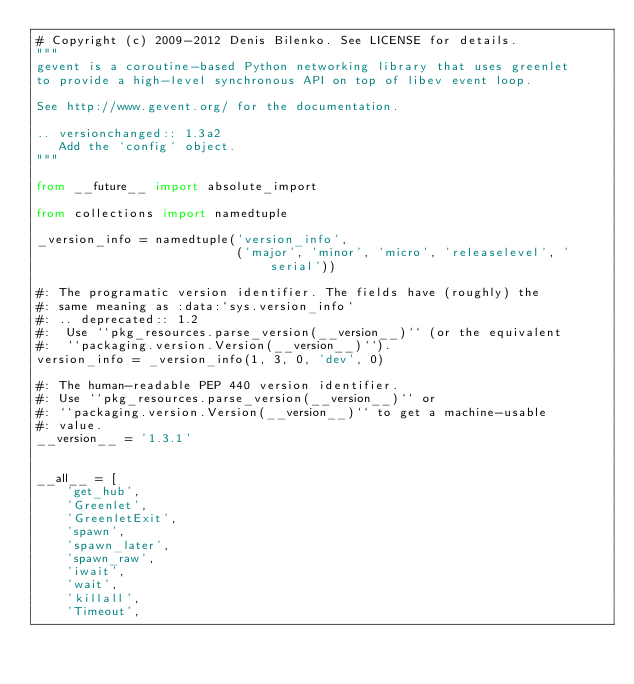<code> <loc_0><loc_0><loc_500><loc_500><_Python_># Copyright (c) 2009-2012 Denis Bilenko. See LICENSE for details.
"""
gevent is a coroutine-based Python networking library that uses greenlet
to provide a high-level synchronous API on top of libev event loop.

See http://www.gevent.org/ for the documentation.

.. versionchanged:: 1.3a2
   Add the `config` object.
"""

from __future__ import absolute_import

from collections import namedtuple

_version_info = namedtuple('version_info',
                           ('major', 'minor', 'micro', 'releaselevel', 'serial'))

#: The programatic version identifier. The fields have (roughly) the
#: same meaning as :data:`sys.version_info`
#: .. deprecated:: 1.2
#:  Use ``pkg_resources.parse_version(__version__)`` (or the equivalent
#:  ``packaging.version.Version(__version__)``).
version_info = _version_info(1, 3, 0, 'dev', 0)

#: The human-readable PEP 440 version identifier.
#: Use ``pkg_resources.parse_version(__version__)`` or
#: ``packaging.version.Version(__version__)`` to get a machine-usable
#: value.
__version__ = '1.3.1'


__all__ = [
    'get_hub',
    'Greenlet',
    'GreenletExit',
    'spawn',
    'spawn_later',
    'spawn_raw',
    'iwait',
    'wait',
    'killall',
    'Timeout',</code> 